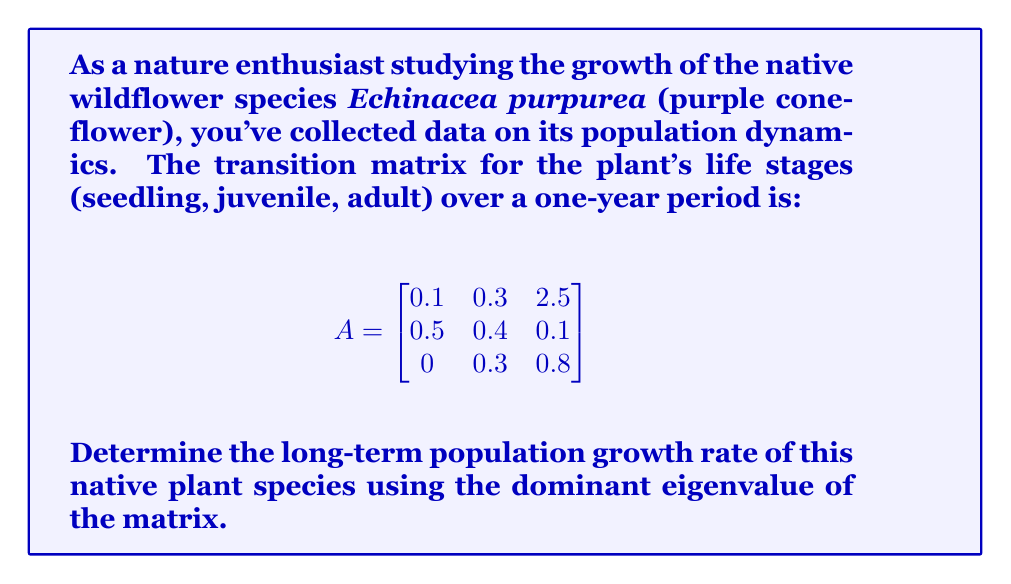Provide a solution to this math problem. To find the long-term population growth rate, we need to calculate the dominant eigenvalue of the transition matrix A. Here's how we do it:

1) First, we need to find the characteristic equation of the matrix:
   $det(A - \lambda I) = 0$

2) Expanding this, we get:
   $$(0.1 - \lambda)(0.4 - \lambda)(0.8 - \lambda) - 0.3 \cdot 0.1 \cdot 0.3 - 2.5 \cdot 0.5 \cdot 0.3 = 0$$

3) Simplifying:
   $$-\lambda^3 + 1.3\lambda^2 - 0.23\lambda - 0.308 = 0$$

4) This cubic equation can be solved using numerical methods or a calculator. The roots (eigenvalues) are approximately:
   $\lambda_1 \approx 1.2746$
   $\lambda_2 \approx 0.0856 + 0.4149i$
   $\lambda_3 \approx 0.0856 - 0.4149i$

5) The dominant eigenvalue is the one with the largest magnitude, which is $\lambda_1 \approx 1.2746$.

6) In population dynamics, the dominant eigenvalue represents the long-term growth rate of the population. A value greater than 1 indicates growth, less than 1 indicates decline, and equal to 1 indicates a stable population.

Therefore, the long-term population growth rate of the purple coneflower is approximately 1.2746, or about 27.46% per year.
Answer: $1.2746$ or $27.46\%$ per year 